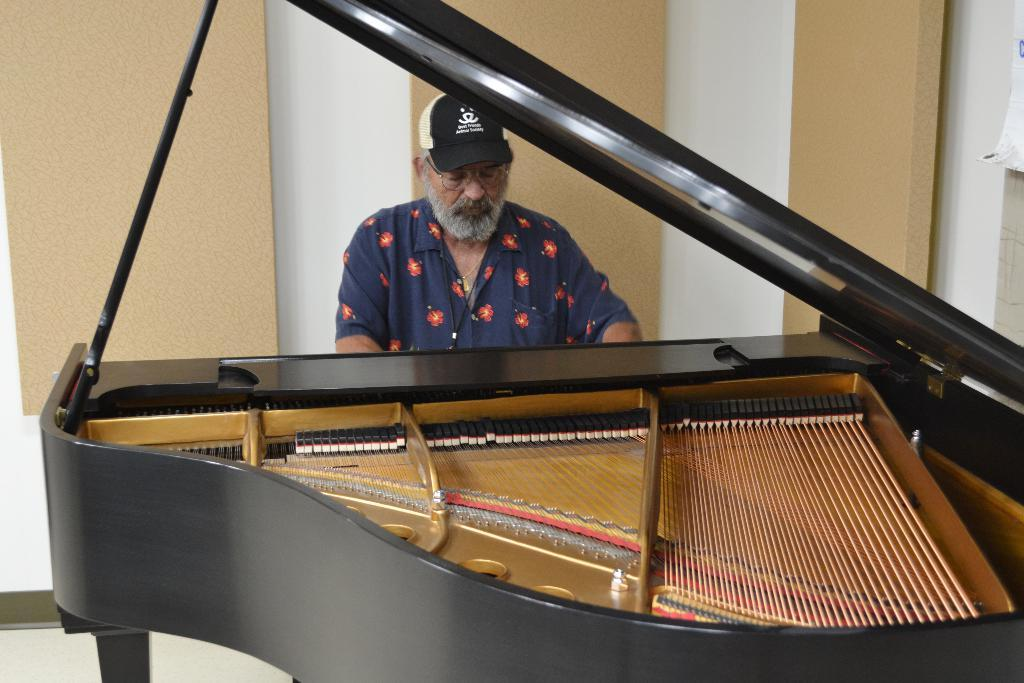What is the man in the image doing? The man is setting and playing a musical instrument. What accessories is the man wearing in the image? The man is wearing spectacles and a cap. What can be seen in the background of the image? There is a wall in the background of the image. What type of cloth is draped over the man's nose in the image? There is no cloth draped over the man's nose in the image. How does the water flow in the image? There is no water present in the image. 